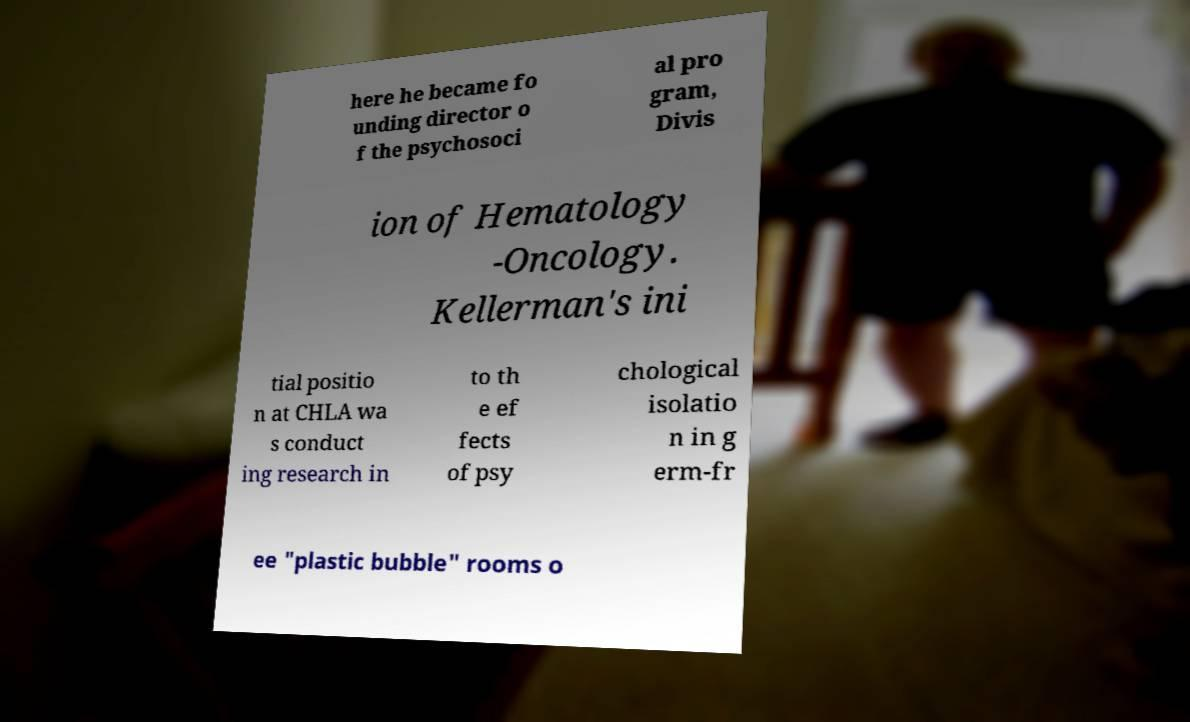Could you assist in decoding the text presented in this image and type it out clearly? here he became fo unding director o f the psychosoci al pro gram, Divis ion of Hematology -Oncology. Kellerman's ini tial positio n at CHLA wa s conduct ing research in to th e ef fects of psy chological isolatio n in g erm-fr ee "plastic bubble" rooms o 